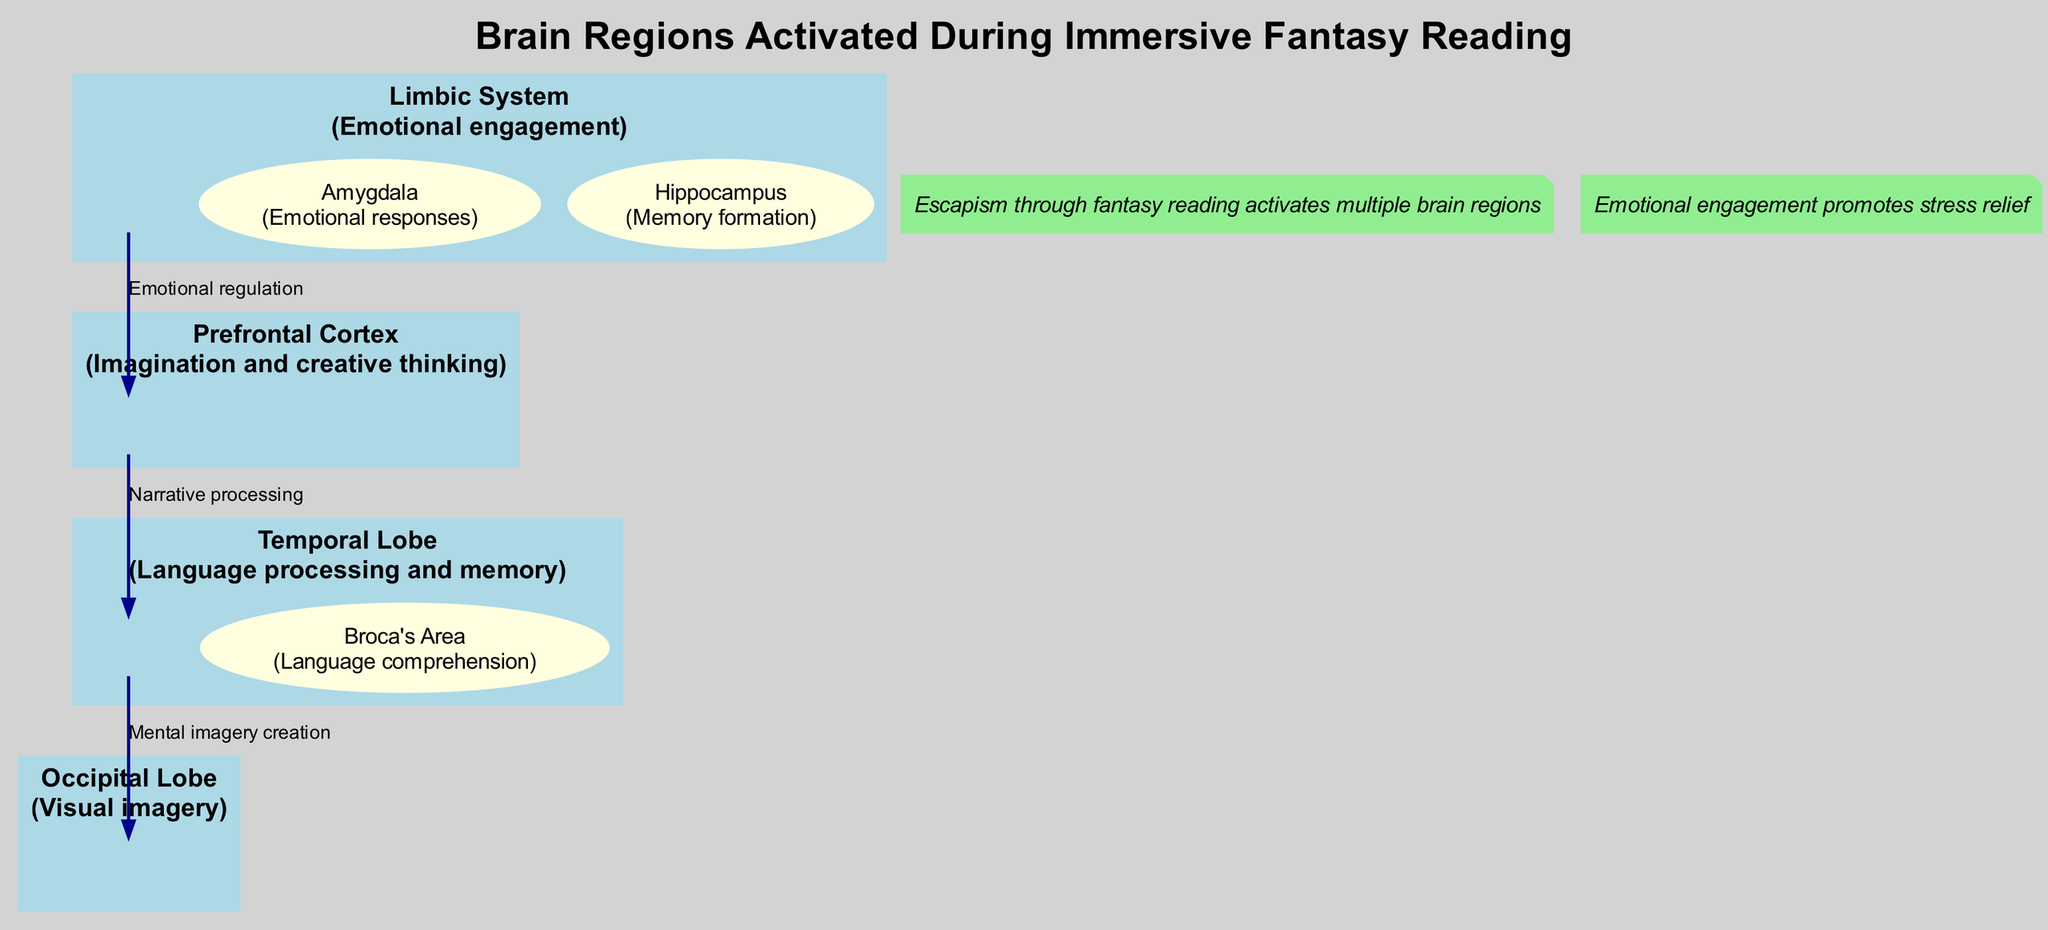What is the function of the Prefrontal Cortex? The Prefrontal Cortex is defined in the diagram as being responsible for 'Imagination and creative thinking'.
Answer: Imagination and creative thinking Which lobe is associated with visual imagery? The Occipital Lobe is stated in the diagram as responsible for 'Visual imagery', making it clear it is the region associated with visual processing.
Answer: Occipital Lobe How many main components are listed in the diagram? Upon reviewing the diagram, there are four main components identified, which are the Prefrontal Cortex, Temporal Lobe, Occipital Lobe, and Limbic System.
Answer: Four What emotional response does the Amygdala regulate? The diagram specifies that the Amygdala is related to 'Emotional responses', thus outlining its function in this context.
Answer: Emotional responses What is the connection labeled as 'Narrative processing' between which two components? The connection labeled 'Narrative processing' is established between the Prefrontal Cortex and the Temporal Lobe, showcasing their interaction in the reading process.
Answer: Prefrontal Cortex and Temporal Lobe Which component is primarily responsible for memory formation? The diagram clearly states that the Hippocampus is responsible for 'Memory formation', identifying it as the crucial region for this function.
Answer: Hippocampus What therapeutic note relates to stress relief? The therapeutic note at the bottom mentions that 'Emotional engagement promotes stress relief', highlighting its significance in the context of fantasy reading.
Answer: Emotional engagement promotes stress relief How does the Limbic System interact with the Prefrontal Cortex? The diagram indicates a connection labeled 'Emotional regulation' from the Limbic System to the Prefrontal Cortex, suggesting that emotional factors influence cognitive processes.
Answer: Emotional regulation Which two lobes are directly connected by the 'Mental imagery creation' label? The diagram shows a direct connection labeled 'Mental imagery creation' from the Temporal Lobe to the Occipital Lobe, highlighting their relationship in the brain during immersive reading.
Answer: Temporal Lobe and Occipital Lobe 